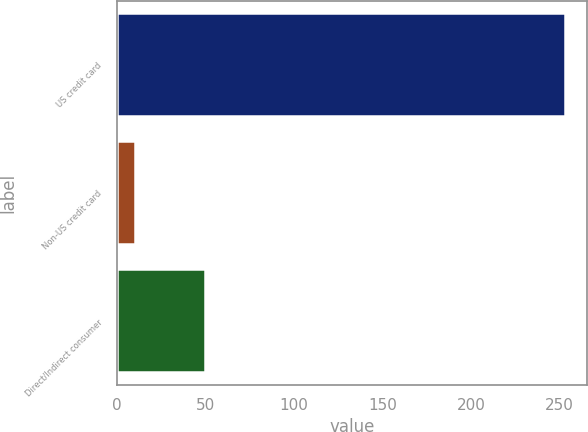Convert chart to OTSL. <chart><loc_0><loc_0><loc_500><loc_500><bar_chart><fcel>US credit card<fcel>Non-US credit card<fcel>Direct/Indirect consumer<nl><fcel>253<fcel>10<fcel>50<nl></chart> 